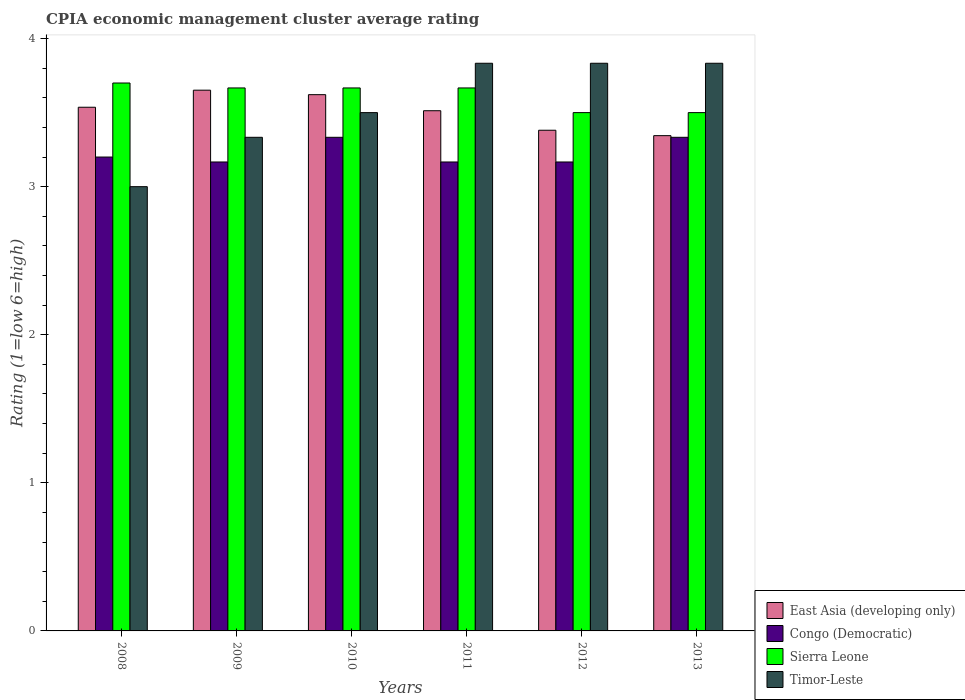How many bars are there on the 5th tick from the left?
Offer a terse response. 4. How many bars are there on the 3rd tick from the right?
Give a very brief answer. 4. What is the label of the 1st group of bars from the left?
Provide a short and direct response. 2008. What is the CPIA rating in Sierra Leone in 2011?
Make the answer very short. 3.67. Across all years, what is the maximum CPIA rating in Congo (Democratic)?
Your response must be concise. 3.33. Across all years, what is the minimum CPIA rating in Congo (Democratic)?
Your response must be concise. 3.17. In which year was the CPIA rating in Sierra Leone maximum?
Your answer should be compact. 2008. What is the total CPIA rating in Timor-Leste in the graph?
Offer a terse response. 21.33. What is the difference between the CPIA rating in East Asia (developing only) in 2008 and that in 2010?
Your answer should be very brief. -0.08. What is the difference between the CPIA rating in Sierra Leone in 2009 and the CPIA rating in East Asia (developing only) in 2013?
Provide a succinct answer. 0.32. What is the average CPIA rating in Congo (Democratic) per year?
Keep it short and to the point. 3.23. In the year 2013, what is the difference between the CPIA rating in Congo (Democratic) and CPIA rating in Timor-Leste?
Your answer should be very brief. -0.5. What is the ratio of the CPIA rating in East Asia (developing only) in 2010 to that in 2012?
Your answer should be very brief. 1.07. Is the difference between the CPIA rating in Congo (Democratic) in 2012 and 2013 greater than the difference between the CPIA rating in Timor-Leste in 2012 and 2013?
Make the answer very short. No. What is the difference between the highest and the lowest CPIA rating in Sierra Leone?
Ensure brevity in your answer.  0.2. In how many years, is the CPIA rating in Sierra Leone greater than the average CPIA rating in Sierra Leone taken over all years?
Ensure brevity in your answer.  4. Is the sum of the CPIA rating in East Asia (developing only) in 2008 and 2010 greater than the maximum CPIA rating in Sierra Leone across all years?
Ensure brevity in your answer.  Yes. What does the 4th bar from the left in 2011 represents?
Make the answer very short. Timor-Leste. What does the 4th bar from the right in 2012 represents?
Offer a very short reply. East Asia (developing only). Is it the case that in every year, the sum of the CPIA rating in Sierra Leone and CPIA rating in East Asia (developing only) is greater than the CPIA rating in Congo (Democratic)?
Provide a succinct answer. Yes. How many bars are there?
Make the answer very short. 24. Are all the bars in the graph horizontal?
Keep it short and to the point. No. What is the difference between two consecutive major ticks on the Y-axis?
Your answer should be very brief. 1. Does the graph contain any zero values?
Your answer should be very brief. No. Where does the legend appear in the graph?
Provide a short and direct response. Bottom right. What is the title of the graph?
Offer a very short reply. CPIA economic management cluster average rating. Does "Latvia" appear as one of the legend labels in the graph?
Provide a short and direct response. No. What is the Rating (1=low 6=high) of East Asia (developing only) in 2008?
Offer a very short reply. 3.54. What is the Rating (1=low 6=high) in Congo (Democratic) in 2008?
Your answer should be very brief. 3.2. What is the Rating (1=low 6=high) of Sierra Leone in 2008?
Your response must be concise. 3.7. What is the Rating (1=low 6=high) in Timor-Leste in 2008?
Give a very brief answer. 3. What is the Rating (1=low 6=high) in East Asia (developing only) in 2009?
Make the answer very short. 3.65. What is the Rating (1=low 6=high) of Congo (Democratic) in 2009?
Make the answer very short. 3.17. What is the Rating (1=low 6=high) in Sierra Leone in 2009?
Give a very brief answer. 3.67. What is the Rating (1=low 6=high) of Timor-Leste in 2009?
Offer a terse response. 3.33. What is the Rating (1=low 6=high) in East Asia (developing only) in 2010?
Your answer should be compact. 3.62. What is the Rating (1=low 6=high) in Congo (Democratic) in 2010?
Offer a terse response. 3.33. What is the Rating (1=low 6=high) in Sierra Leone in 2010?
Your answer should be very brief. 3.67. What is the Rating (1=low 6=high) of East Asia (developing only) in 2011?
Provide a succinct answer. 3.51. What is the Rating (1=low 6=high) of Congo (Democratic) in 2011?
Your answer should be compact. 3.17. What is the Rating (1=low 6=high) in Sierra Leone in 2011?
Your answer should be compact. 3.67. What is the Rating (1=low 6=high) of Timor-Leste in 2011?
Make the answer very short. 3.83. What is the Rating (1=low 6=high) of East Asia (developing only) in 2012?
Offer a very short reply. 3.38. What is the Rating (1=low 6=high) in Congo (Democratic) in 2012?
Offer a very short reply. 3.17. What is the Rating (1=low 6=high) of Timor-Leste in 2012?
Give a very brief answer. 3.83. What is the Rating (1=low 6=high) of East Asia (developing only) in 2013?
Make the answer very short. 3.34. What is the Rating (1=low 6=high) in Congo (Democratic) in 2013?
Offer a terse response. 3.33. What is the Rating (1=low 6=high) in Sierra Leone in 2013?
Your answer should be very brief. 3.5. What is the Rating (1=low 6=high) of Timor-Leste in 2013?
Offer a very short reply. 3.83. Across all years, what is the maximum Rating (1=low 6=high) of East Asia (developing only)?
Give a very brief answer. 3.65. Across all years, what is the maximum Rating (1=low 6=high) of Congo (Democratic)?
Ensure brevity in your answer.  3.33. Across all years, what is the maximum Rating (1=low 6=high) of Sierra Leone?
Keep it short and to the point. 3.7. Across all years, what is the maximum Rating (1=low 6=high) in Timor-Leste?
Make the answer very short. 3.83. Across all years, what is the minimum Rating (1=low 6=high) of East Asia (developing only)?
Keep it short and to the point. 3.34. Across all years, what is the minimum Rating (1=low 6=high) of Congo (Democratic)?
Make the answer very short. 3.17. What is the total Rating (1=low 6=high) in East Asia (developing only) in the graph?
Offer a very short reply. 21.05. What is the total Rating (1=low 6=high) in Congo (Democratic) in the graph?
Offer a very short reply. 19.37. What is the total Rating (1=low 6=high) in Sierra Leone in the graph?
Offer a terse response. 21.7. What is the total Rating (1=low 6=high) of Timor-Leste in the graph?
Ensure brevity in your answer.  21.33. What is the difference between the Rating (1=low 6=high) of East Asia (developing only) in 2008 and that in 2009?
Your answer should be compact. -0.12. What is the difference between the Rating (1=low 6=high) in Congo (Democratic) in 2008 and that in 2009?
Ensure brevity in your answer.  0.03. What is the difference between the Rating (1=low 6=high) in Timor-Leste in 2008 and that in 2009?
Offer a terse response. -0.33. What is the difference between the Rating (1=low 6=high) in East Asia (developing only) in 2008 and that in 2010?
Your answer should be very brief. -0.08. What is the difference between the Rating (1=low 6=high) in Congo (Democratic) in 2008 and that in 2010?
Offer a very short reply. -0.13. What is the difference between the Rating (1=low 6=high) in East Asia (developing only) in 2008 and that in 2011?
Provide a succinct answer. 0.02. What is the difference between the Rating (1=low 6=high) in Congo (Democratic) in 2008 and that in 2011?
Offer a very short reply. 0.03. What is the difference between the Rating (1=low 6=high) in Sierra Leone in 2008 and that in 2011?
Provide a short and direct response. 0.03. What is the difference between the Rating (1=low 6=high) in Timor-Leste in 2008 and that in 2011?
Offer a terse response. -0.83. What is the difference between the Rating (1=low 6=high) in East Asia (developing only) in 2008 and that in 2012?
Make the answer very short. 0.16. What is the difference between the Rating (1=low 6=high) in Congo (Democratic) in 2008 and that in 2012?
Your answer should be very brief. 0.03. What is the difference between the Rating (1=low 6=high) in Timor-Leste in 2008 and that in 2012?
Give a very brief answer. -0.83. What is the difference between the Rating (1=low 6=high) of East Asia (developing only) in 2008 and that in 2013?
Offer a very short reply. 0.19. What is the difference between the Rating (1=low 6=high) of Congo (Democratic) in 2008 and that in 2013?
Offer a terse response. -0.13. What is the difference between the Rating (1=low 6=high) of Sierra Leone in 2008 and that in 2013?
Give a very brief answer. 0.2. What is the difference between the Rating (1=low 6=high) of Timor-Leste in 2008 and that in 2013?
Provide a succinct answer. -0.83. What is the difference between the Rating (1=low 6=high) of East Asia (developing only) in 2009 and that in 2010?
Provide a succinct answer. 0.03. What is the difference between the Rating (1=low 6=high) in Sierra Leone in 2009 and that in 2010?
Your answer should be compact. 0. What is the difference between the Rating (1=low 6=high) in East Asia (developing only) in 2009 and that in 2011?
Give a very brief answer. 0.14. What is the difference between the Rating (1=low 6=high) of Sierra Leone in 2009 and that in 2011?
Offer a terse response. 0. What is the difference between the Rating (1=low 6=high) of Timor-Leste in 2009 and that in 2011?
Provide a short and direct response. -0.5. What is the difference between the Rating (1=low 6=high) of East Asia (developing only) in 2009 and that in 2012?
Provide a succinct answer. 0.27. What is the difference between the Rating (1=low 6=high) in Sierra Leone in 2009 and that in 2012?
Your answer should be compact. 0.17. What is the difference between the Rating (1=low 6=high) of Timor-Leste in 2009 and that in 2012?
Make the answer very short. -0.5. What is the difference between the Rating (1=low 6=high) in East Asia (developing only) in 2009 and that in 2013?
Offer a terse response. 0.31. What is the difference between the Rating (1=low 6=high) of Timor-Leste in 2009 and that in 2013?
Your answer should be very brief. -0.5. What is the difference between the Rating (1=low 6=high) in East Asia (developing only) in 2010 and that in 2011?
Keep it short and to the point. 0.11. What is the difference between the Rating (1=low 6=high) of Congo (Democratic) in 2010 and that in 2011?
Provide a succinct answer. 0.17. What is the difference between the Rating (1=low 6=high) of Sierra Leone in 2010 and that in 2011?
Offer a terse response. 0. What is the difference between the Rating (1=low 6=high) in East Asia (developing only) in 2010 and that in 2012?
Offer a very short reply. 0.24. What is the difference between the Rating (1=low 6=high) of Congo (Democratic) in 2010 and that in 2012?
Your answer should be very brief. 0.17. What is the difference between the Rating (1=low 6=high) of Sierra Leone in 2010 and that in 2012?
Offer a very short reply. 0.17. What is the difference between the Rating (1=low 6=high) in Timor-Leste in 2010 and that in 2012?
Give a very brief answer. -0.33. What is the difference between the Rating (1=low 6=high) of East Asia (developing only) in 2010 and that in 2013?
Provide a succinct answer. 0.28. What is the difference between the Rating (1=low 6=high) in Timor-Leste in 2010 and that in 2013?
Your answer should be compact. -0.33. What is the difference between the Rating (1=low 6=high) in East Asia (developing only) in 2011 and that in 2012?
Your answer should be compact. 0.13. What is the difference between the Rating (1=low 6=high) in East Asia (developing only) in 2011 and that in 2013?
Offer a terse response. 0.17. What is the difference between the Rating (1=low 6=high) in Congo (Democratic) in 2011 and that in 2013?
Give a very brief answer. -0.17. What is the difference between the Rating (1=low 6=high) in East Asia (developing only) in 2012 and that in 2013?
Give a very brief answer. 0.04. What is the difference between the Rating (1=low 6=high) of Sierra Leone in 2012 and that in 2013?
Provide a succinct answer. 0. What is the difference between the Rating (1=low 6=high) of East Asia (developing only) in 2008 and the Rating (1=low 6=high) of Congo (Democratic) in 2009?
Offer a very short reply. 0.37. What is the difference between the Rating (1=low 6=high) of East Asia (developing only) in 2008 and the Rating (1=low 6=high) of Sierra Leone in 2009?
Make the answer very short. -0.13. What is the difference between the Rating (1=low 6=high) of East Asia (developing only) in 2008 and the Rating (1=low 6=high) of Timor-Leste in 2009?
Provide a short and direct response. 0.2. What is the difference between the Rating (1=low 6=high) in Congo (Democratic) in 2008 and the Rating (1=low 6=high) in Sierra Leone in 2009?
Offer a very short reply. -0.47. What is the difference between the Rating (1=low 6=high) of Congo (Democratic) in 2008 and the Rating (1=low 6=high) of Timor-Leste in 2009?
Provide a succinct answer. -0.13. What is the difference between the Rating (1=low 6=high) in Sierra Leone in 2008 and the Rating (1=low 6=high) in Timor-Leste in 2009?
Provide a short and direct response. 0.37. What is the difference between the Rating (1=low 6=high) of East Asia (developing only) in 2008 and the Rating (1=low 6=high) of Congo (Democratic) in 2010?
Ensure brevity in your answer.  0.2. What is the difference between the Rating (1=low 6=high) in East Asia (developing only) in 2008 and the Rating (1=low 6=high) in Sierra Leone in 2010?
Your answer should be compact. -0.13. What is the difference between the Rating (1=low 6=high) in East Asia (developing only) in 2008 and the Rating (1=low 6=high) in Timor-Leste in 2010?
Your answer should be very brief. 0.04. What is the difference between the Rating (1=low 6=high) of Congo (Democratic) in 2008 and the Rating (1=low 6=high) of Sierra Leone in 2010?
Provide a succinct answer. -0.47. What is the difference between the Rating (1=low 6=high) of Congo (Democratic) in 2008 and the Rating (1=low 6=high) of Timor-Leste in 2010?
Offer a very short reply. -0.3. What is the difference between the Rating (1=low 6=high) of East Asia (developing only) in 2008 and the Rating (1=low 6=high) of Congo (Democratic) in 2011?
Your answer should be compact. 0.37. What is the difference between the Rating (1=low 6=high) of East Asia (developing only) in 2008 and the Rating (1=low 6=high) of Sierra Leone in 2011?
Your answer should be compact. -0.13. What is the difference between the Rating (1=low 6=high) in East Asia (developing only) in 2008 and the Rating (1=low 6=high) in Timor-Leste in 2011?
Provide a short and direct response. -0.3. What is the difference between the Rating (1=low 6=high) of Congo (Democratic) in 2008 and the Rating (1=low 6=high) of Sierra Leone in 2011?
Your response must be concise. -0.47. What is the difference between the Rating (1=low 6=high) in Congo (Democratic) in 2008 and the Rating (1=low 6=high) in Timor-Leste in 2011?
Keep it short and to the point. -0.63. What is the difference between the Rating (1=low 6=high) of Sierra Leone in 2008 and the Rating (1=low 6=high) of Timor-Leste in 2011?
Give a very brief answer. -0.13. What is the difference between the Rating (1=low 6=high) of East Asia (developing only) in 2008 and the Rating (1=low 6=high) of Congo (Democratic) in 2012?
Offer a terse response. 0.37. What is the difference between the Rating (1=low 6=high) of East Asia (developing only) in 2008 and the Rating (1=low 6=high) of Sierra Leone in 2012?
Keep it short and to the point. 0.04. What is the difference between the Rating (1=low 6=high) of East Asia (developing only) in 2008 and the Rating (1=low 6=high) of Timor-Leste in 2012?
Offer a terse response. -0.3. What is the difference between the Rating (1=low 6=high) of Congo (Democratic) in 2008 and the Rating (1=low 6=high) of Timor-Leste in 2012?
Your answer should be very brief. -0.63. What is the difference between the Rating (1=low 6=high) of Sierra Leone in 2008 and the Rating (1=low 6=high) of Timor-Leste in 2012?
Provide a succinct answer. -0.13. What is the difference between the Rating (1=low 6=high) in East Asia (developing only) in 2008 and the Rating (1=low 6=high) in Congo (Democratic) in 2013?
Provide a succinct answer. 0.2. What is the difference between the Rating (1=low 6=high) in East Asia (developing only) in 2008 and the Rating (1=low 6=high) in Sierra Leone in 2013?
Your answer should be compact. 0.04. What is the difference between the Rating (1=low 6=high) of East Asia (developing only) in 2008 and the Rating (1=low 6=high) of Timor-Leste in 2013?
Ensure brevity in your answer.  -0.3. What is the difference between the Rating (1=low 6=high) of Congo (Democratic) in 2008 and the Rating (1=low 6=high) of Sierra Leone in 2013?
Your answer should be compact. -0.3. What is the difference between the Rating (1=low 6=high) of Congo (Democratic) in 2008 and the Rating (1=low 6=high) of Timor-Leste in 2013?
Provide a short and direct response. -0.63. What is the difference between the Rating (1=low 6=high) in Sierra Leone in 2008 and the Rating (1=low 6=high) in Timor-Leste in 2013?
Provide a short and direct response. -0.13. What is the difference between the Rating (1=low 6=high) of East Asia (developing only) in 2009 and the Rating (1=low 6=high) of Congo (Democratic) in 2010?
Provide a succinct answer. 0.32. What is the difference between the Rating (1=low 6=high) of East Asia (developing only) in 2009 and the Rating (1=low 6=high) of Sierra Leone in 2010?
Keep it short and to the point. -0.02. What is the difference between the Rating (1=low 6=high) of East Asia (developing only) in 2009 and the Rating (1=low 6=high) of Timor-Leste in 2010?
Ensure brevity in your answer.  0.15. What is the difference between the Rating (1=low 6=high) of Sierra Leone in 2009 and the Rating (1=low 6=high) of Timor-Leste in 2010?
Ensure brevity in your answer.  0.17. What is the difference between the Rating (1=low 6=high) of East Asia (developing only) in 2009 and the Rating (1=low 6=high) of Congo (Democratic) in 2011?
Offer a very short reply. 0.48. What is the difference between the Rating (1=low 6=high) of East Asia (developing only) in 2009 and the Rating (1=low 6=high) of Sierra Leone in 2011?
Give a very brief answer. -0.02. What is the difference between the Rating (1=low 6=high) of East Asia (developing only) in 2009 and the Rating (1=low 6=high) of Timor-Leste in 2011?
Your answer should be compact. -0.18. What is the difference between the Rating (1=low 6=high) in Sierra Leone in 2009 and the Rating (1=low 6=high) in Timor-Leste in 2011?
Ensure brevity in your answer.  -0.17. What is the difference between the Rating (1=low 6=high) of East Asia (developing only) in 2009 and the Rating (1=low 6=high) of Congo (Democratic) in 2012?
Your response must be concise. 0.48. What is the difference between the Rating (1=low 6=high) in East Asia (developing only) in 2009 and the Rating (1=low 6=high) in Sierra Leone in 2012?
Give a very brief answer. 0.15. What is the difference between the Rating (1=low 6=high) in East Asia (developing only) in 2009 and the Rating (1=low 6=high) in Timor-Leste in 2012?
Provide a short and direct response. -0.18. What is the difference between the Rating (1=low 6=high) of Congo (Democratic) in 2009 and the Rating (1=low 6=high) of Sierra Leone in 2012?
Provide a succinct answer. -0.33. What is the difference between the Rating (1=low 6=high) of Congo (Democratic) in 2009 and the Rating (1=low 6=high) of Timor-Leste in 2012?
Make the answer very short. -0.67. What is the difference between the Rating (1=low 6=high) in Sierra Leone in 2009 and the Rating (1=low 6=high) in Timor-Leste in 2012?
Provide a short and direct response. -0.17. What is the difference between the Rating (1=low 6=high) in East Asia (developing only) in 2009 and the Rating (1=low 6=high) in Congo (Democratic) in 2013?
Make the answer very short. 0.32. What is the difference between the Rating (1=low 6=high) in East Asia (developing only) in 2009 and the Rating (1=low 6=high) in Sierra Leone in 2013?
Make the answer very short. 0.15. What is the difference between the Rating (1=low 6=high) in East Asia (developing only) in 2009 and the Rating (1=low 6=high) in Timor-Leste in 2013?
Your answer should be very brief. -0.18. What is the difference between the Rating (1=low 6=high) of Congo (Democratic) in 2009 and the Rating (1=low 6=high) of Sierra Leone in 2013?
Give a very brief answer. -0.33. What is the difference between the Rating (1=low 6=high) of Sierra Leone in 2009 and the Rating (1=low 6=high) of Timor-Leste in 2013?
Give a very brief answer. -0.17. What is the difference between the Rating (1=low 6=high) of East Asia (developing only) in 2010 and the Rating (1=low 6=high) of Congo (Democratic) in 2011?
Give a very brief answer. 0.45. What is the difference between the Rating (1=low 6=high) in East Asia (developing only) in 2010 and the Rating (1=low 6=high) in Sierra Leone in 2011?
Offer a very short reply. -0.05. What is the difference between the Rating (1=low 6=high) in East Asia (developing only) in 2010 and the Rating (1=low 6=high) in Timor-Leste in 2011?
Offer a terse response. -0.21. What is the difference between the Rating (1=low 6=high) of Congo (Democratic) in 2010 and the Rating (1=low 6=high) of Sierra Leone in 2011?
Provide a short and direct response. -0.33. What is the difference between the Rating (1=low 6=high) of Sierra Leone in 2010 and the Rating (1=low 6=high) of Timor-Leste in 2011?
Your answer should be very brief. -0.17. What is the difference between the Rating (1=low 6=high) in East Asia (developing only) in 2010 and the Rating (1=low 6=high) in Congo (Democratic) in 2012?
Your answer should be compact. 0.45. What is the difference between the Rating (1=low 6=high) in East Asia (developing only) in 2010 and the Rating (1=low 6=high) in Sierra Leone in 2012?
Provide a short and direct response. 0.12. What is the difference between the Rating (1=low 6=high) of East Asia (developing only) in 2010 and the Rating (1=low 6=high) of Timor-Leste in 2012?
Your answer should be very brief. -0.21. What is the difference between the Rating (1=low 6=high) of Congo (Democratic) in 2010 and the Rating (1=low 6=high) of Sierra Leone in 2012?
Provide a short and direct response. -0.17. What is the difference between the Rating (1=low 6=high) in East Asia (developing only) in 2010 and the Rating (1=low 6=high) in Congo (Democratic) in 2013?
Your answer should be compact. 0.29. What is the difference between the Rating (1=low 6=high) in East Asia (developing only) in 2010 and the Rating (1=low 6=high) in Sierra Leone in 2013?
Offer a very short reply. 0.12. What is the difference between the Rating (1=low 6=high) in East Asia (developing only) in 2010 and the Rating (1=low 6=high) in Timor-Leste in 2013?
Keep it short and to the point. -0.21. What is the difference between the Rating (1=low 6=high) of Congo (Democratic) in 2010 and the Rating (1=low 6=high) of Sierra Leone in 2013?
Offer a very short reply. -0.17. What is the difference between the Rating (1=low 6=high) of Congo (Democratic) in 2010 and the Rating (1=low 6=high) of Timor-Leste in 2013?
Your response must be concise. -0.5. What is the difference between the Rating (1=low 6=high) in Sierra Leone in 2010 and the Rating (1=low 6=high) in Timor-Leste in 2013?
Your answer should be compact. -0.17. What is the difference between the Rating (1=low 6=high) of East Asia (developing only) in 2011 and the Rating (1=low 6=high) of Congo (Democratic) in 2012?
Give a very brief answer. 0.35. What is the difference between the Rating (1=low 6=high) in East Asia (developing only) in 2011 and the Rating (1=low 6=high) in Sierra Leone in 2012?
Your response must be concise. 0.01. What is the difference between the Rating (1=low 6=high) in East Asia (developing only) in 2011 and the Rating (1=low 6=high) in Timor-Leste in 2012?
Make the answer very short. -0.32. What is the difference between the Rating (1=low 6=high) of Congo (Democratic) in 2011 and the Rating (1=low 6=high) of Sierra Leone in 2012?
Ensure brevity in your answer.  -0.33. What is the difference between the Rating (1=low 6=high) in Sierra Leone in 2011 and the Rating (1=low 6=high) in Timor-Leste in 2012?
Make the answer very short. -0.17. What is the difference between the Rating (1=low 6=high) in East Asia (developing only) in 2011 and the Rating (1=low 6=high) in Congo (Democratic) in 2013?
Offer a very short reply. 0.18. What is the difference between the Rating (1=low 6=high) in East Asia (developing only) in 2011 and the Rating (1=low 6=high) in Sierra Leone in 2013?
Offer a very short reply. 0.01. What is the difference between the Rating (1=low 6=high) of East Asia (developing only) in 2011 and the Rating (1=low 6=high) of Timor-Leste in 2013?
Your answer should be very brief. -0.32. What is the difference between the Rating (1=low 6=high) of Congo (Democratic) in 2011 and the Rating (1=low 6=high) of Sierra Leone in 2013?
Your answer should be very brief. -0.33. What is the difference between the Rating (1=low 6=high) of Sierra Leone in 2011 and the Rating (1=low 6=high) of Timor-Leste in 2013?
Your response must be concise. -0.17. What is the difference between the Rating (1=low 6=high) of East Asia (developing only) in 2012 and the Rating (1=low 6=high) of Congo (Democratic) in 2013?
Keep it short and to the point. 0.05. What is the difference between the Rating (1=low 6=high) in East Asia (developing only) in 2012 and the Rating (1=low 6=high) in Sierra Leone in 2013?
Ensure brevity in your answer.  -0.12. What is the difference between the Rating (1=low 6=high) of East Asia (developing only) in 2012 and the Rating (1=low 6=high) of Timor-Leste in 2013?
Provide a short and direct response. -0.45. What is the average Rating (1=low 6=high) in East Asia (developing only) per year?
Provide a short and direct response. 3.51. What is the average Rating (1=low 6=high) of Congo (Democratic) per year?
Make the answer very short. 3.23. What is the average Rating (1=low 6=high) in Sierra Leone per year?
Give a very brief answer. 3.62. What is the average Rating (1=low 6=high) in Timor-Leste per year?
Make the answer very short. 3.56. In the year 2008, what is the difference between the Rating (1=low 6=high) in East Asia (developing only) and Rating (1=low 6=high) in Congo (Democratic)?
Offer a very short reply. 0.34. In the year 2008, what is the difference between the Rating (1=low 6=high) in East Asia (developing only) and Rating (1=low 6=high) in Sierra Leone?
Keep it short and to the point. -0.16. In the year 2008, what is the difference between the Rating (1=low 6=high) of East Asia (developing only) and Rating (1=low 6=high) of Timor-Leste?
Keep it short and to the point. 0.54. In the year 2008, what is the difference between the Rating (1=low 6=high) of Congo (Democratic) and Rating (1=low 6=high) of Sierra Leone?
Keep it short and to the point. -0.5. In the year 2008, what is the difference between the Rating (1=low 6=high) of Congo (Democratic) and Rating (1=low 6=high) of Timor-Leste?
Make the answer very short. 0.2. In the year 2009, what is the difference between the Rating (1=low 6=high) of East Asia (developing only) and Rating (1=low 6=high) of Congo (Democratic)?
Offer a terse response. 0.48. In the year 2009, what is the difference between the Rating (1=low 6=high) of East Asia (developing only) and Rating (1=low 6=high) of Sierra Leone?
Provide a short and direct response. -0.02. In the year 2009, what is the difference between the Rating (1=low 6=high) in East Asia (developing only) and Rating (1=low 6=high) in Timor-Leste?
Keep it short and to the point. 0.32. In the year 2010, what is the difference between the Rating (1=low 6=high) of East Asia (developing only) and Rating (1=low 6=high) of Congo (Democratic)?
Offer a terse response. 0.29. In the year 2010, what is the difference between the Rating (1=low 6=high) of East Asia (developing only) and Rating (1=low 6=high) of Sierra Leone?
Offer a terse response. -0.05. In the year 2010, what is the difference between the Rating (1=low 6=high) in East Asia (developing only) and Rating (1=low 6=high) in Timor-Leste?
Ensure brevity in your answer.  0.12. In the year 2010, what is the difference between the Rating (1=low 6=high) of Congo (Democratic) and Rating (1=low 6=high) of Timor-Leste?
Provide a succinct answer. -0.17. In the year 2010, what is the difference between the Rating (1=low 6=high) of Sierra Leone and Rating (1=low 6=high) of Timor-Leste?
Give a very brief answer. 0.17. In the year 2011, what is the difference between the Rating (1=low 6=high) of East Asia (developing only) and Rating (1=low 6=high) of Congo (Democratic)?
Your answer should be very brief. 0.35. In the year 2011, what is the difference between the Rating (1=low 6=high) in East Asia (developing only) and Rating (1=low 6=high) in Sierra Leone?
Give a very brief answer. -0.15. In the year 2011, what is the difference between the Rating (1=low 6=high) in East Asia (developing only) and Rating (1=low 6=high) in Timor-Leste?
Offer a very short reply. -0.32. In the year 2011, what is the difference between the Rating (1=low 6=high) of Congo (Democratic) and Rating (1=low 6=high) of Sierra Leone?
Give a very brief answer. -0.5. In the year 2011, what is the difference between the Rating (1=low 6=high) in Sierra Leone and Rating (1=low 6=high) in Timor-Leste?
Provide a succinct answer. -0.17. In the year 2012, what is the difference between the Rating (1=low 6=high) in East Asia (developing only) and Rating (1=low 6=high) in Congo (Democratic)?
Make the answer very short. 0.21. In the year 2012, what is the difference between the Rating (1=low 6=high) of East Asia (developing only) and Rating (1=low 6=high) of Sierra Leone?
Ensure brevity in your answer.  -0.12. In the year 2012, what is the difference between the Rating (1=low 6=high) of East Asia (developing only) and Rating (1=low 6=high) of Timor-Leste?
Your answer should be very brief. -0.45. In the year 2012, what is the difference between the Rating (1=low 6=high) of Congo (Democratic) and Rating (1=low 6=high) of Sierra Leone?
Give a very brief answer. -0.33. In the year 2012, what is the difference between the Rating (1=low 6=high) of Congo (Democratic) and Rating (1=low 6=high) of Timor-Leste?
Give a very brief answer. -0.67. In the year 2013, what is the difference between the Rating (1=low 6=high) in East Asia (developing only) and Rating (1=low 6=high) in Congo (Democratic)?
Make the answer very short. 0.01. In the year 2013, what is the difference between the Rating (1=low 6=high) of East Asia (developing only) and Rating (1=low 6=high) of Sierra Leone?
Keep it short and to the point. -0.16. In the year 2013, what is the difference between the Rating (1=low 6=high) of East Asia (developing only) and Rating (1=low 6=high) of Timor-Leste?
Give a very brief answer. -0.49. In the year 2013, what is the difference between the Rating (1=low 6=high) in Sierra Leone and Rating (1=low 6=high) in Timor-Leste?
Make the answer very short. -0.33. What is the ratio of the Rating (1=low 6=high) of East Asia (developing only) in 2008 to that in 2009?
Make the answer very short. 0.97. What is the ratio of the Rating (1=low 6=high) of Congo (Democratic) in 2008 to that in 2009?
Your response must be concise. 1.01. What is the ratio of the Rating (1=low 6=high) in Sierra Leone in 2008 to that in 2009?
Offer a terse response. 1.01. What is the ratio of the Rating (1=low 6=high) in Timor-Leste in 2008 to that in 2009?
Provide a short and direct response. 0.9. What is the ratio of the Rating (1=low 6=high) in East Asia (developing only) in 2008 to that in 2010?
Your answer should be compact. 0.98. What is the ratio of the Rating (1=low 6=high) in Sierra Leone in 2008 to that in 2010?
Offer a terse response. 1.01. What is the ratio of the Rating (1=low 6=high) of Congo (Democratic) in 2008 to that in 2011?
Keep it short and to the point. 1.01. What is the ratio of the Rating (1=low 6=high) of Sierra Leone in 2008 to that in 2011?
Provide a short and direct response. 1.01. What is the ratio of the Rating (1=low 6=high) of Timor-Leste in 2008 to that in 2011?
Offer a terse response. 0.78. What is the ratio of the Rating (1=low 6=high) in East Asia (developing only) in 2008 to that in 2012?
Provide a short and direct response. 1.05. What is the ratio of the Rating (1=low 6=high) in Congo (Democratic) in 2008 to that in 2012?
Make the answer very short. 1.01. What is the ratio of the Rating (1=low 6=high) of Sierra Leone in 2008 to that in 2012?
Your answer should be very brief. 1.06. What is the ratio of the Rating (1=low 6=high) of Timor-Leste in 2008 to that in 2012?
Your answer should be very brief. 0.78. What is the ratio of the Rating (1=low 6=high) in East Asia (developing only) in 2008 to that in 2013?
Your answer should be compact. 1.06. What is the ratio of the Rating (1=low 6=high) of Congo (Democratic) in 2008 to that in 2013?
Offer a terse response. 0.96. What is the ratio of the Rating (1=low 6=high) in Sierra Leone in 2008 to that in 2013?
Ensure brevity in your answer.  1.06. What is the ratio of the Rating (1=low 6=high) of Timor-Leste in 2008 to that in 2013?
Your answer should be very brief. 0.78. What is the ratio of the Rating (1=low 6=high) in East Asia (developing only) in 2009 to that in 2010?
Provide a short and direct response. 1.01. What is the ratio of the Rating (1=low 6=high) in Congo (Democratic) in 2009 to that in 2010?
Give a very brief answer. 0.95. What is the ratio of the Rating (1=low 6=high) in Sierra Leone in 2009 to that in 2010?
Offer a terse response. 1. What is the ratio of the Rating (1=low 6=high) of East Asia (developing only) in 2009 to that in 2011?
Provide a succinct answer. 1.04. What is the ratio of the Rating (1=low 6=high) of Timor-Leste in 2009 to that in 2011?
Give a very brief answer. 0.87. What is the ratio of the Rating (1=low 6=high) of Sierra Leone in 2009 to that in 2012?
Offer a terse response. 1.05. What is the ratio of the Rating (1=low 6=high) of Timor-Leste in 2009 to that in 2012?
Offer a very short reply. 0.87. What is the ratio of the Rating (1=low 6=high) of East Asia (developing only) in 2009 to that in 2013?
Your answer should be compact. 1.09. What is the ratio of the Rating (1=low 6=high) of Sierra Leone in 2009 to that in 2013?
Provide a short and direct response. 1.05. What is the ratio of the Rating (1=low 6=high) of Timor-Leste in 2009 to that in 2013?
Provide a succinct answer. 0.87. What is the ratio of the Rating (1=low 6=high) of East Asia (developing only) in 2010 to that in 2011?
Provide a succinct answer. 1.03. What is the ratio of the Rating (1=low 6=high) in Congo (Democratic) in 2010 to that in 2011?
Offer a terse response. 1.05. What is the ratio of the Rating (1=low 6=high) in East Asia (developing only) in 2010 to that in 2012?
Your answer should be very brief. 1.07. What is the ratio of the Rating (1=low 6=high) of Congo (Democratic) in 2010 to that in 2012?
Give a very brief answer. 1.05. What is the ratio of the Rating (1=low 6=high) in Sierra Leone in 2010 to that in 2012?
Provide a succinct answer. 1.05. What is the ratio of the Rating (1=low 6=high) in East Asia (developing only) in 2010 to that in 2013?
Keep it short and to the point. 1.08. What is the ratio of the Rating (1=low 6=high) in Sierra Leone in 2010 to that in 2013?
Offer a terse response. 1.05. What is the ratio of the Rating (1=low 6=high) of East Asia (developing only) in 2011 to that in 2012?
Provide a short and direct response. 1.04. What is the ratio of the Rating (1=low 6=high) of Congo (Democratic) in 2011 to that in 2012?
Keep it short and to the point. 1. What is the ratio of the Rating (1=low 6=high) in Sierra Leone in 2011 to that in 2012?
Your answer should be very brief. 1.05. What is the ratio of the Rating (1=low 6=high) of Timor-Leste in 2011 to that in 2012?
Your response must be concise. 1. What is the ratio of the Rating (1=low 6=high) of East Asia (developing only) in 2011 to that in 2013?
Ensure brevity in your answer.  1.05. What is the ratio of the Rating (1=low 6=high) in Sierra Leone in 2011 to that in 2013?
Give a very brief answer. 1.05. What is the ratio of the Rating (1=low 6=high) of Timor-Leste in 2011 to that in 2013?
Give a very brief answer. 1. What is the ratio of the Rating (1=low 6=high) in East Asia (developing only) in 2012 to that in 2013?
Your answer should be very brief. 1.01. What is the ratio of the Rating (1=low 6=high) of Congo (Democratic) in 2012 to that in 2013?
Your answer should be very brief. 0.95. What is the ratio of the Rating (1=low 6=high) of Sierra Leone in 2012 to that in 2013?
Provide a short and direct response. 1. What is the ratio of the Rating (1=low 6=high) of Timor-Leste in 2012 to that in 2013?
Offer a terse response. 1. What is the difference between the highest and the second highest Rating (1=low 6=high) of East Asia (developing only)?
Provide a succinct answer. 0.03. What is the difference between the highest and the second highest Rating (1=low 6=high) of Sierra Leone?
Ensure brevity in your answer.  0.03. What is the difference between the highest and the second highest Rating (1=low 6=high) in Timor-Leste?
Your answer should be compact. 0. What is the difference between the highest and the lowest Rating (1=low 6=high) in East Asia (developing only)?
Provide a succinct answer. 0.31. What is the difference between the highest and the lowest Rating (1=low 6=high) of Sierra Leone?
Your response must be concise. 0.2. 